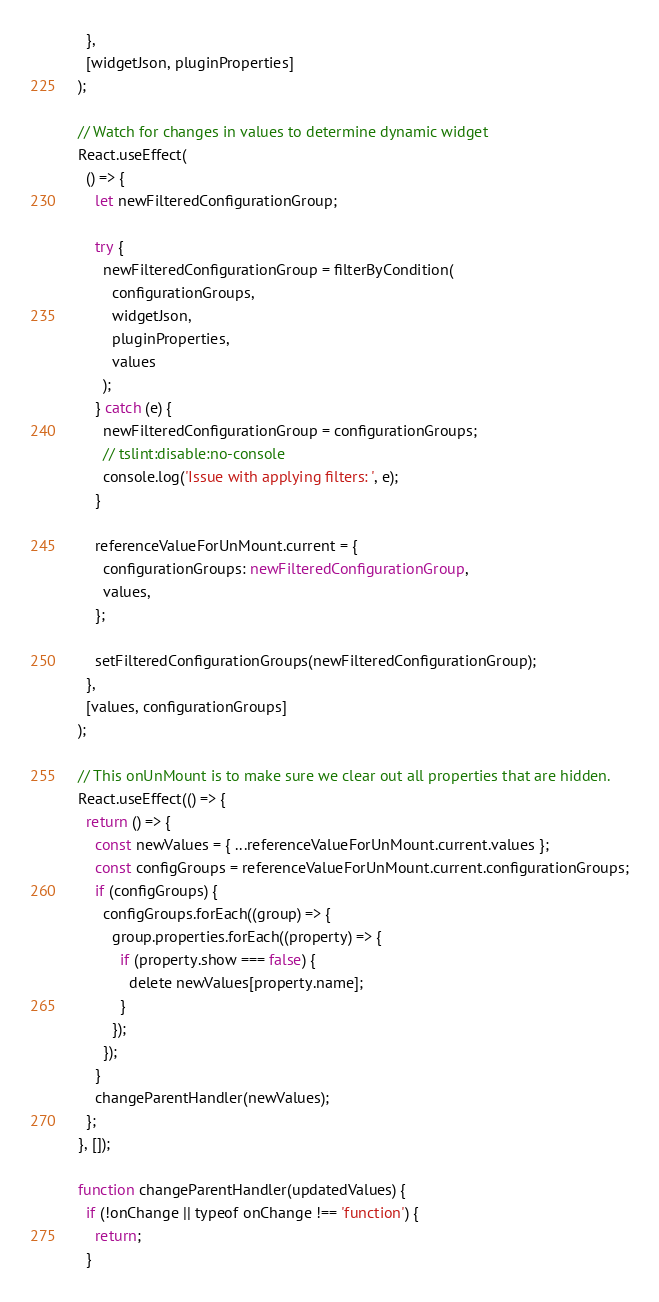<code> <loc_0><loc_0><loc_500><loc_500><_TypeScript_>    },
    [widgetJson, pluginProperties]
  );

  // Watch for changes in values to determine dynamic widget
  React.useEffect(
    () => {
      let newFilteredConfigurationGroup;

      try {
        newFilteredConfigurationGroup = filterByCondition(
          configurationGroups,
          widgetJson,
          pluginProperties,
          values
        );
      } catch (e) {
        newFilteredConfigurationGroup = configurationGroups;
        // tslint:disable:no-console
        console.log('Issue with applying filters: ', e);
      }

      referenceValueForUnMount.current = {
        configurationGroups: newFilteredConfigurationGroup,
        values,
      };

      setFilteredConfigurationGroups(newFilteredConfigurationGroup);
    },
    [values, configurationGroups]
  );

  // This onUnMount is to make sure we clear out all properties that are hidden.
  React.useEffect(() => {
    return () => {
      const newValues = { ...referenceValueForUnMount.current.values };
      const configGroups = referenceValueForUnMount.current.configurationGroups;
      if (configGroups) {
        configGroups.forEach((group) => {
          group.properties.forEach((property) => {
            if (property.show === false) {
              delete newValues[property.name];
            }
          });
        });
      }
      changeParentHandler(newValues);
    };
  }, []);

  function changeParentHandler(updatedValues) {
    if (!onChange || typeof onChange !== 'function') {
      return;
    }
</code> 